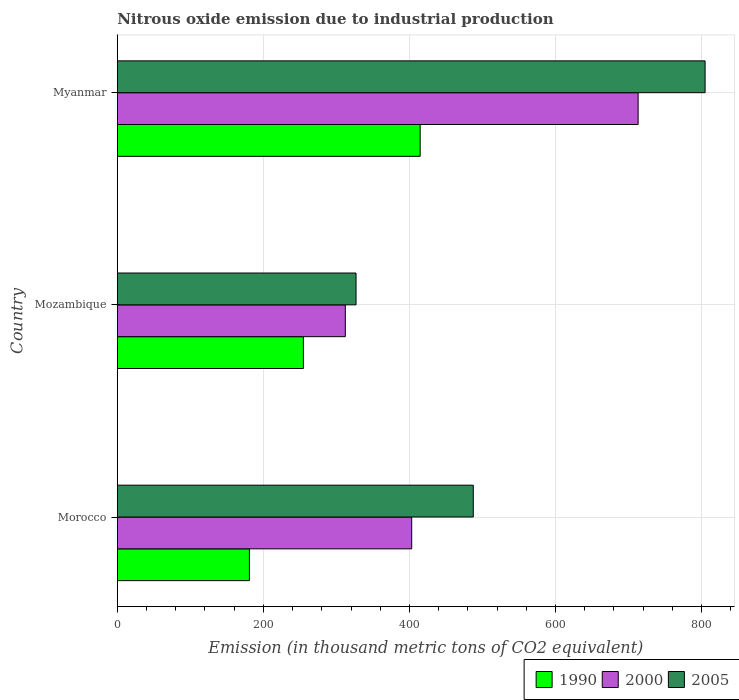How many groups of bars are there?
Your answer should be very brief. 3. Are the number of bars per tick equal to the number of legend labels?
Provide a short and direct response. Yes. Are the number of bars on each tick of the Y-axis equal?
Your answer should be very brief. Yes. How many bars are there on the 2nd tick from the top?
Your answer should be very brief. 3. How many bars are there on the 1st tick from the bottom?
Your answer should be compact. 3. What is the label of the 3rd group of bars from the top?
Your answer should be very brief. Morocco. In how many cases, is the number of bars for a given country not equal to the number of legend labels?
Keep it short and to the point. 0. What is the amount of nitrous oxide emitted in 2000 in Mozambique?
Make the answer very short. 312.2. Across all countries, what is the maximum amount of nitrous oxide emitted in 1990?
Offer a terse response. 414.7. Across all countries, what is the minimum amount of nitrous oxide emitted in 2000?
Offer a very short reply. 312.2. In which country was the amount of nitrous oxide emitted in 1990 maximum?
Offer a very short reply. Myanmar. In which country was the amount of nitrous oxide emitted in 1990 minimum?
Your answer should be compact. Morocco. What is the total amount of nitrous oxide emitted in 2000 in the graph?
Your response must be concise. 1428.4. What is the difference between the amount of nitrous oxide emitted in 2005 in Mozambique and that in Myanmar?
Keep it short and to the point. -477.9. What is the difference between the amount of nitrous oxide emitted in 2005 in Morocco and the amount of nitrous oxide emitted in 2000 in Mozambique?
Offer a very short reply. 175.2. What is the average amount of nitrous oxide emitted in 1990 per country?
Provide a succinct answer. 283.47. What is the difference between the amount of nitrous oxide emitted in 1990 and amount of nitrous oxide emitted in 2000 in Myanmar?
Keep it short and to the point. -298.4. What is the ratio of the amount of nitrous oxide emitted in 1990 in Morocco to that in Myanmar?
Offer a terse response. 0.44. Is the difference between the amount of nitrous oxide emitted in 1990 in Morocco and Myanmar greater than the difference between the amount of nitrous oxide emitted in 2000 in Morocco and Myanmar?
Offer a very short reply. Yes. What is the difference between the highest and the second highest amount of nitrous oxide emitted in 1990?
Give a very brief answer. 159.9. What is the difference between the highest and the lowest amount of nitrous oxide emitted in 1990?
Make the answer very short. 233.8. In how many countries, is the amount of nitrous oxide emitted in 1990 greater than the average amount of nitrous oxide emitted in 1990 taken over all countries?
Give a very brief answer. 1. What does the 3rd bar from the top in Morocco represents?
Your answer should be compact. 1990. What does the 2nd bar from the bottom in Myanmar represents?
Your response must be concise. 2000. How many bars are there?
Offer a terse response. 9. How many legend labels are there?
Give a very brief answer. 3. What is the title of the graph?
Offer a terse response. Nitrous oxide emission due to industrial production. What is the label or title of the X-axis?
Make the answer very short. Emission (in thousand metric tons of CO2 equivalent). What is the Emission (in thousand metric tons of CO2 equivalent) in 1990 in Morocco?
Provide a succinct answer. 180.9. What is the Emission (in thousand metric tons of CO2 equivalent) in 2000 in Morocco?
Make the answer very short. 403.1. What is the Emission (in thousand metric tons of CO2 equivalent) of 2005 in Morocco?
Provide a succinct answer. 487.4. What is the Emission (in thousand metric tons of CO2 equivalent) of 1990 in Mozambique?
Give a very brief answer. 254.8. What is the Emission (in thousand metric tons of CO2 equivalent) in 2000 in Mozambique?
Offer a terse response. 312.2. What is the Emission (in thousand metric tons of CO2 equivalent) in 2005 in Mozambique?
Keep it short and to the point. 326.9. What is the Emission (in thousand metric tons of CO2 equivalent) in 1990 in Myanmar?
Make the answer very short. 414.7. What is the Emission (in thousand metric tons of CO2 equivalent) of 2000 in Myanmar?
Offer a very short reply. 713.1. What is the Emission (in thousand metric tons of CO2 equivalent) in 2005 in Myanmar?
Offer a terse response. 804.8. Across all countries, what is the maximum Emission (in thousand metric tons of CO2 equivalent) in 1990?
Give a very brief answer. 414.7. Across all countries, what is the maximum Emission (in thousand metric tons of CO2 equivalent) in 2000?
Offer a very short reply. 713.1. Across all countries, what is the maximum Emission (in thousand metric tons of CO2 equivalent) of 2005?
Offer a very short reply. 804.8. Across all countries, what is the minimum Emission (in thousand metric tons of CO2 equivalent) in 1990?
Give a very brief answer. 180.9. Across all countries, what is the minimum Emission (in thousand metric tons of CO2 equivalent) in 2000?
Ensure brevity in your answer.  312.2. Across all countries, what is the minimum Emission (in thousand metric tons of CO2 equivalent) in 2005?
Offer a terse response. 326.9. What is the total Emission (in thousand metric tons of CO2 equivalent) in 1990 in the graph?
Keep it short and to the point. 850.4. What is the total Emission (in thousand metric tons of CO2 equivalent) of 2000 in the graph?
Ensure brevity in your answer.  1428.4. What is the total Emission (in thousand metric tons of CO2 equivalent) in 2005 in the graph?
Provide a succinct answer. 1619.1. What is the difference between the Emission (in thousand metric tons of CO2 equivalent) in 1990 in Morocco and that in Mozambique?
Your answer should be compact. -73.9. What is the difference between the Emission (in thousand metric tons of CO2 equivalent) of 2000 in Morocco and that in Mozambique?
Provide a short and direct response. 90.9. What is the difference between the Emission (in thousand metric tons of CO2 equivalent) of 2005 in Morocco and that in Mozambique?
Provide a short and direct response. 160.5. What is the difference between the Emission (in thousand metric tons of CO2 equivalent) of 1990 in Morocco and that in Myanmar?
Give a very brief answer. -233.8. What is the difference between the Emission (in thousand metric tons of CO2 equivalent) of 2000 in Morocco and that in Myanmar?
Your answer should be very brief. -310. What is the difference between the Emission (in thousand metric tons of CO2 equivalent) in 2005 in Morocco and that in Myanmar?
Provide a succinct answer. -317.4. What is the difference between the Emission (in thousand metric tons of CO2 equivalent) in 1990 in Mozambique and that in Myanmar?
Ensure brevity in your answer.  -159.9. What is the difference between the Emission (in thousand metric tons of CO2 equivalent) of 2000 in Mozambique and that in Myanmar?
Your response must be concise. -400.9. What is the difference between the Emission (in thousand metric tons of CO2 equivalent) in 2005 in Mozambique and that in Myanmar?
Provide a short and direct response. -477.9. What is the difference between the Emission (in thousand metric tons of CO2 equivalent) in 1990 in Morocco and the Emission (in thousand metric tons of CO2 equivalent) in 2000 in Mozambique?
Offer a very short reply. -131.3. What is the difference between the Emission (in thousand metric tons of CO2 equivalent) of 1990 in Morocco and the Emission (in thousand metric tons of CO2 equivalent) of 2005 in Mozambique?
Provide a short and direct response. -146. What is the difference between the Emission (in thousand metric tons of CO2 equivalent) of 2000 in Morocco and the Emission (in thousand metric tons of CO2 equivalent) of 2005 in Mozambique?
Keep it short and to the point. 76.2. What is the difference between the Emission (in thousand metric tons of CO2 equivalent) in 1990 in Morocco and the Emission (in thousand metric tons of CO2 equivalent) in 2000 in Myanmar?
Your response must be concise. -532.2. What is the difference between the Emission (in thousand metric tons of CO2 equivalent) of 1990 in Morocco and the Emission (in thousand metric tons of CO2 equivalent) of 2005 in Myanmar?
Ensure brevity in your answer.  -623.9. What is the difference between the Emission (in thousand metric tons of CO2 equivalent) in 2000 in Morocco and the Emission (in thousand metric tons of CO2 equivalent) in 2005 in Myanmar?
Make the answer very short. -401.7. What is the difference between the Emission (in thousand metric tons of CO2 equivalent) in 1990 in Mozambique and the Emission (in thousand metric tons of CO2 equivalent) in 2000 in Myanmar?
Your answer should be compact. -458.3. What is the difference between the Emission (in thousand metric tons of CO2 equivalent) in 1990 in Mozambique and the Emission (in thousand metric tons of CO2 equivalent) in 2005 in Myanmar?
Keep it short and to the point. -550. What is the difference between the Emission (in thousand metric tons of CO2 equivalent) of 2000 in Mozambique and the Emission (in thousand metric tons of CO2 equivalent) of 2005 in Myanmar?
Provide a short and direct response. -492.6. What is the average Emission (in thousand metric tons of CO2 equivalent) of 1990 per country?
Offer a terse response. 283.47. What is the average Emission (in thousand metric tons of CO2 equivalent) of 2000 per country?
Give a very brief answer. 476.13. What is the average Emission (in thousand metric tons of CO2 equivalent) in 2005 per country?
Make the answer very short. 539.7. What is the difference between the Emission (in thousand metric tons of CO2 equivalent) in 1990 and Emission (in thousand metric tons of CO2 equivalent) in 2000 in Morocco?
Your response must be concise. -222.2. What is the difference between the Emission (in thousand metric tons of CO2 equivalent) in 1990 and Emission (in thousand metric tons of CO2 equivalent) in 2005 in Morocco?
Provide a succinct answer. -306.5. What is the difference between the Emission (in thousand metric tons of CO2 equivalent) of 2000 and Emission (in thousand metric tons of CO2 equivalent) of 2005 in Morocco?
Give a very brief answer. -84.3. What is the difference between the Emission (in thousand metric tons of CO2 equivalent) in 1990 and Emission (in thousand metric tons of CO2 equivalent) in 2000 in Mozambique?
Make the answer very short. -57.4. What is the difference between the Emission (in thousand metric tons of CO2 equivalent) in 1990 and Emission (in thousand metric tons of CO2 equivalent) in 2005 in Mozambique?
Your answer should be very brief. -72.1. What is the difference between the Emission (in thousand metric tons of CO2 equivalent) in 2000 and Emission (in thousand metric tons of CO2 equivalent) in 2005 in Mozambique?
Your answer should be compact. -14.7. What is the difference between the Emission (in thousand metric tons of CO2 equivalent) of 1990 and Emission (in thousand metric tons of CO2 equivalent) of 2000 in Myanmar?
Provide a short and direct response. -298.4. What is the difference between the Emission (in thousand metric tons of CO2 equivalent) of 1990 and Emission (in thousand metric tons of CO2 equivalent) of 2005 in Myanmar?
Offer a terse response. -390.1. What is the difference between the Emission (in thousand metric tons of CO2 equivalent) of 2000 and Emission (in thousand metric tons of CO2 equivalent) of 2005 in Myanmar?
Keep it short and to the point. -91.7. What is the ratio of the Emission (in thousand metric tons of CO2 equivalent) in 1990 in Morocco to that in Mozambique?
Keep it short and to the point. 0.71. What is the ratio of the Emission (in thousand metric tons of CO2 equivalent) in 2000 in Morocco to that in Mozambique?
Offer a terse response. 1.29. What is the ratio of the Emission (in thousand metric tons of CO2 equivalent) of 2005 in Morocco to that in Mozambique?
Your response must be concise. 1.49. What is the ratio of the Emission (in thousand metric tons of CO2 equivalent) of 1990 in Morocco to that in Myanmar?
Provide a short and direct response. 0.44. What is the ratio of the Emission (in thousand metric tons of CO2 equivalent) of 2000 in Morocco to that in Myanmar?
Give a very brief answer. 0.57. What is the ratio of the Emission (in thousand metric tons of CO2 equivalent) in 2005 in Morocco to that in Myanmar?
Give a very brief answer. 0.61. What is the ratio of the Emission (in thousand metric tons of CO2 equivalent) of 1990 in Mozambique to that in Myanmar?
Ensure brevity in your answer.  0.61. What is the ratio of the Emission (in thousand metric tons of CO2 equivalent) of 2000 in Mozambique to that in Myanmar?
Provide a short and direct response. 0.44. What is the ratio of the Emission (in thousand metric tons of CO2 equivalent) of 2005 in Mozambique to that in Myanmar?
Your answer should be very brief. 0.41. What is the difference between the highest and the second highest Emission (in thousand metric tons of CO2 equivalent) of 1990?
Your answer should be very brief. 159.9. What is the difference between the highest and the second highest Emission (in thousand metric tons of CO2 equivalent) of 2000?
Provide a short and direct response. 310. What is the difference between the highest and the second highest Emission (in thousand metric tons of CO2 equivalent) of 2005?
Provide a short and direct response. 317.4. What is the difference between the highest and the lowest Emission (in thousand metric tons of CO2 equivalent) in 1990?
Ensure brevity in your answer.  233.8. What is the difference between the highest and the lowest Emission (in thousand metric tons of CO2 equivalent) in 2000?
Provide a succinct answer. 400.9. What is the difference between the highest and the lowest Emission (in thousand metric tons of CO2 equivalent) in 2005?
Ensure brevity in your answer.  477.9. 